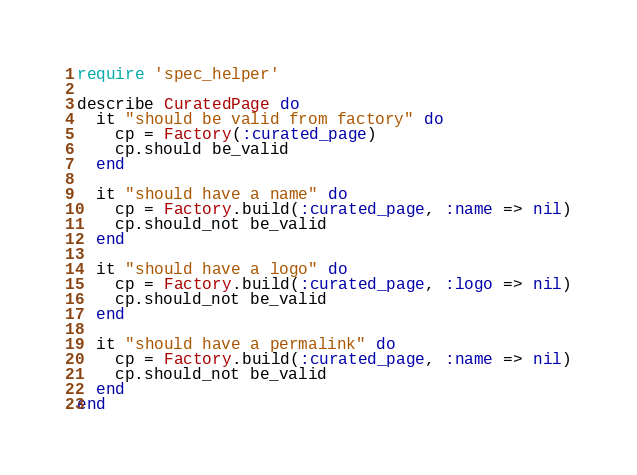<code> <loc_0><loc_0><loc_500><loc_500><_Ruby_>require 'spec_helper'

describe CuratedPage do
  it "should be valid from factory" do
    cp = Factory(:curated_page)
    cp.should be_valid
  end

  it "should have a name" do
    cp = Factory.build(:curated_page, :name => nil)
    cp.should_not be_valid
  end

  it "should have a logo" do
    cp = Factory.build(:curated_page, :logo => nil)
    cp.should_not be_valid
  end
  
  it "should have a permalink" do
    cp = Factory.build(:curated_page, :name => nil)
    cp.should_not be_valid
  end
end
</code> 